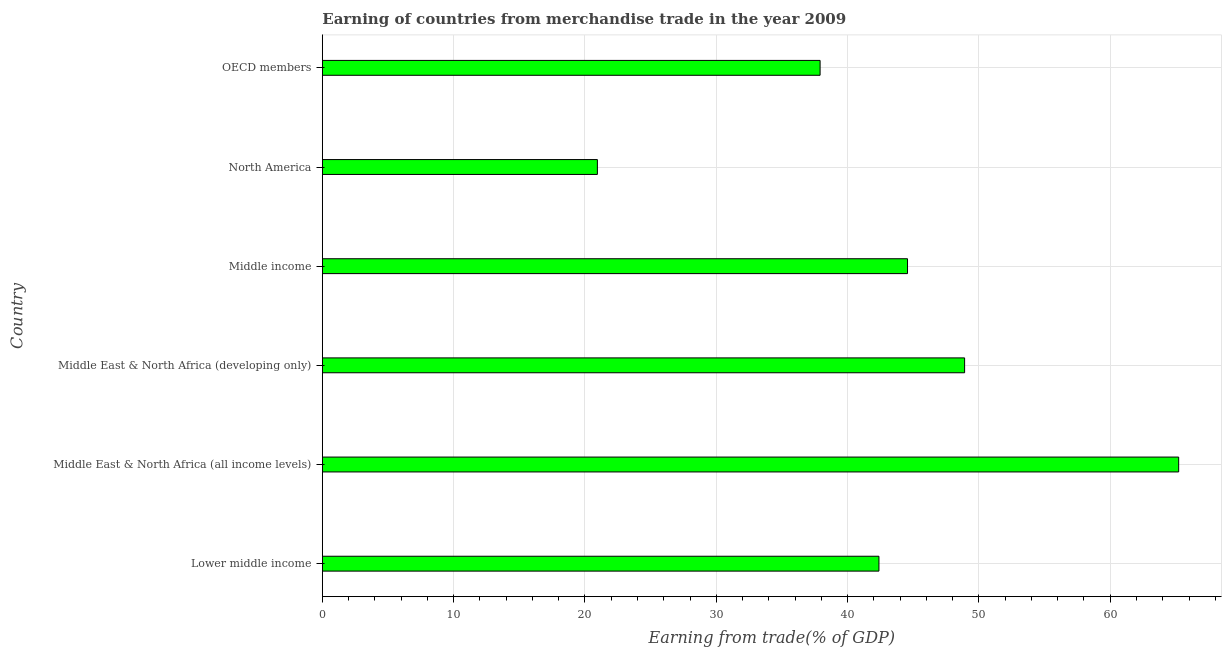Does the graph contain any zero values?
Offer a very short reply. No. What is the title of the graph?
Your response must be concise. Earning of countries from merchandise trade in the year 2009. What is the label or title of the X-axis?
Provide a succinct answer. Earning from trade(% of GDP). What is the earning from merchandise trade in OECD members?
Your answer should be very brief. 37.9. Across all countries, what is the maximum earning from merchandise trade?
Provide a succinct answer. 65.21. Across all countries, what is the minimum earning from merchandise trade?
Ensure brevity in your answer.  20.95. In which country was the earning from merchandise trade maximum?
Your answer should be compact. Middle East & North Africa (all income levels). What is the sum of the earning from merchandise trade?
Your answer should be very brief. 259.92. What is the difference between the earning from merchandise trade in Middle East & North Africa (all income levels) and Middle income?
Your response must be concise. 20.65. What is the average earning from merchandise trade per country?
Give a very brief answer. 43.32. What is the median earning from merchandise trade?
Provide a short and direct response. 43.47. In how many countries, is the earning from merchandise trade greater than 40 %?
Your response must be concise. 4. What is the ratio of the earning from merchandise trade in Middle East & North Africa (developing only) to that in North America?
Offer a terse response. 2.33. Is the earning from merchandise trade in Lower middle income less than that in Middle income?
Your response must be concise. Yes. What is the difference between the highest and the second highest earning from merchandise trade?
Keep it short and to the point. 16.3. What is the difference between the highest and the lowest earning from merchandise trade?
Offer a terse response. 44.26. In how many countries, is the earning from merchandise trade greater than the average earning from merchandise trade taken over all countries?
Keep it short and to the point. 3. Are all the bars in the graph horizontal?
Your answer should be very brief. Yes. How many countries are there in the graph?
Keep it short and to the point. 6. What is the Earning from trade(% of GDP) of Lower middle income?
Your response must be concise. 42.39. What is the Earning from trade(% of GDP) in Middle East & North Africa (all income levels)?
Offer a terse response. 65.21. What is the Earning from trade(% of GDP) in Middle East & North Africa (developing only)?
Your answer should be compact. 48.91. What is the Earning from trade(% of GDP) of Middle income?
Offer a very short reply. 44.56. What is the Earning from trade(% of GDP) of North America?
Keep it short and to the point. 20.95. What is the Earning from trade(% of GDP) in OECD members?
Keep it short and to the point. 37.9. What is the difference between the Earning from trade(% of GDP) in Lower middle income and Middle East & North Africa (all income levels)?
Your answer should be very brief. -22.82. What is the difference between the Earning from trade(% of GDP) in Lower middle income and Middle East & North Africa (developing only)?
Ensure brevity in your answer.  -6.52. What is the difference between the Earning from trade(% of GDP) in Lower middle income and Middle income?
Make the answer very short. -2.18. What is the difference between the Earning from trade(% of GDP) in Lower middle income and North America?
Make the answer very short. 21.44. What is the difference between the Earning from trade(% of GDP) in Lower middle income and OECD members?
Your response must be concise. 4.48. What is the difference between the Earning from trade(% of GDP) in Middle East & North Africa (all income levels) and Middle East & North Africa (developing only)?
Give a very brief answer. 16.3. What is the difference between the Earning from trade(% of GDP) in Middle East & North Africa (all income levels) and Middle income?
Offer a terse response. 20.65. What is the difference between the Earning from trade(% of GDP) in Middle East & North Africa (all income levels) and North America?
Provide a succinct answer. 44.26. What is the difference between the Earning from trade(% of GDP) in Middle East & North Africa (all income levels) and OECD members?
Offer a terse response. 27.31. What is the difference between the Earning from trade(% of GDP) in Middle East & North Africa (developing only) and Middle income?
Your answer should be very brief. 4.35. What is the difference between the Earning from trade(% of GDP) in Middle East & North Africa (developing only) and North America?
Give a very brief answer. 27.96. What is the difference between the Earning from trade(% of GDP) in Middle East & North Africa (developing only) and OECD members?
Make the answer very short. 11. What is the difference between the Earning from trade(% of GDP) in Middle income and North America?
Ensure brevity in your answer.  23.62. What is the difference between the Earning from trade(% of GDP) in Middle income and OECD members?
Provide a short and direct response. 6.66. What is the difference between the Earning from trade(% of GDP) in North America and OECD members?
Keep it short and to the point. -16.96. What is the ratio of the Earning from trade(% of GDP) in Lower middle income to that in Middle East & North Africa (all income levels)?
Make the answer very short. 0.65. What is the ratio of the Earning from trade(% of GDP) in Lower middle income to that in Middle East & North Africa (developing only)?
Offer a terse response. 0.87. What is the ratio of the Earning from trade(% of GDP) in Lower middle income to that in Middle income?
Your response must be concise. 0.95. What is the ratio of the Earning from trade(% of GDP) in Lower middle income to that in North America?
Provide a short and direct response. 2.02. What is the ratio of the Earning from trade(% of GDP) in Lower middle income to that in OECD members?
Provide a short and direct response. 1.12. What is the ratio of the Earning from trade(% of GDP) in Middle East & North Africa (all income levels) to that in Middle East & North Africa (developing only)?
Your answer should be compact. 1.33. What is the ratio of the Earning from trade(% of GDP) in Middle East & North Africa (all income levels) to that in Middle income?
Your answer should be compact. 1.46. What is the ratio of the Earning from trade(% of GDP) in Middle East & North Africa (all income levels) to that in North America?
Your answer should be very brief. 3.11. What is the ratio of the Earning from trade(% of GDP) in Middle East & North Africa (all income levels) to that in OECD members?
Your answer should be compact. 1.72. What is the ratio of the Earning from trade(% of GDP) in Middle East & North Africa (developing only) to that in Middle income?
Your response must be concise. 1.1. What is the ratio of the Earning from trade(% of GDP) in Middle East & North Africa (developing only) to that in North America?
Your answer should be compact. 2.33. What is the ratio of the Earning from trade(% of GDP) in Middle East & North Africa (developing only) to that in OECD members?
Offer a very short reply. 1.29. What is the ratio of the Earning from trade(% of GDP) in Middle income to that in North America?
Your answer should be very brief. 2.13. What is the ratio of the Earning from trade(% of GDP) in Middle income to that in OECD members?
Your answer should be very brief. 1.18. What is the ratio of the Earning from trade(% of GDP) in North America to that in OECD members?
Provide a succinct answer. 0.55. 